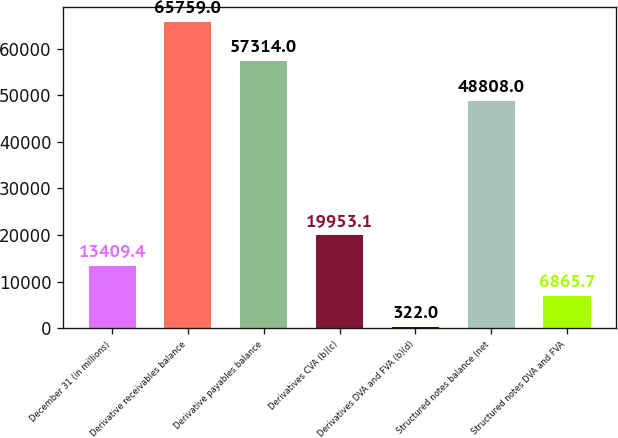Convert chart to OTSL. <chart><loc_0><loc_0><loc_500><loc_500><bar_chart><fcel>December 31 (in millions)<fcel>Derivative receivables balance<fcel>Derivative payables balance<fcel>Derivatives CVA (b)(c)<fcel>Derivatives DVA and FVA (b)(d)<fcel>Structured notes balance (net<fcel>Structured notes DVA and FVA<nl><fcel>13409.4<fcel>65759<fcel>57314<fcel>19953.1<fcel>322<fcel>48808<fcel>6865.7<nl></chart> 